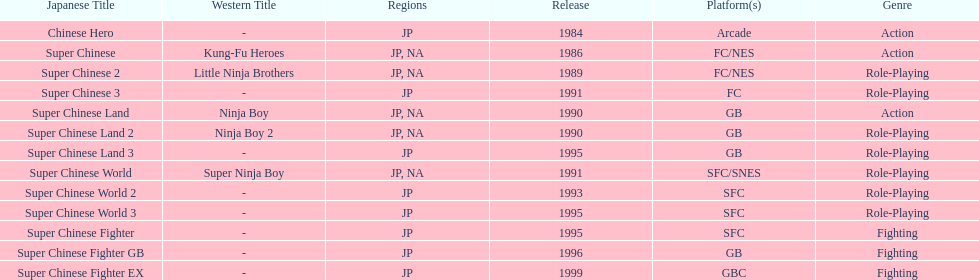How many action games have been introduced in north america? 2. 